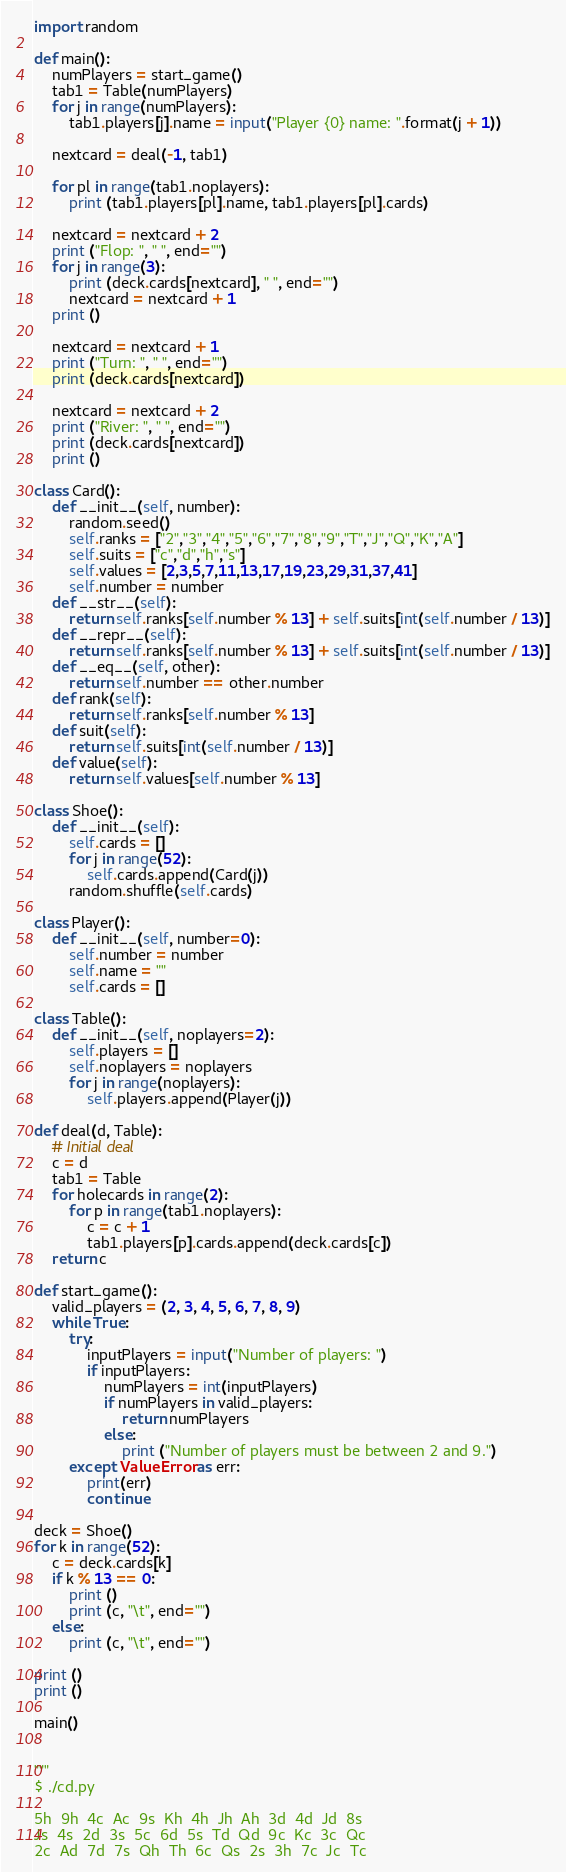<code> <loc_0><loc_0><loc_500><loc_500><_Python_>
import random

def main():
    numPlayers = start_game()
    tab1 = Table(numPlayers)
    for j in range(numPlayers):
        tab1.players[j].name = input("Player {0} name: ".format(j + 1))

    nextcard = deal(-1, tab1)

    for pl in range(tab1.noplayers):
        print (tab1.players[pl].name, tab1.players[pl].cards)

    nextcard = nextcard + 2
    print ("Flop: ", " ", end="")
    for j in range(3):
        print (deck.cards[nextcard], " ", end="")
        nextcard = nextcard + 1
    print ()

    nextcard = nextcard + 1
    print ("Turn: ", " ", end="")
    print (deck.cards[nextcard])

    nextcard = nextcard + 2
    print ("River: ", " ", end="")
    print (deck.cards[nextcard])
    print ()

class Card():
    def __init__(self, number):
        random.seed()
        self.ranks = ["2","3","4","5","6","7","8","9","T","J","Q","K","A"]
        self.suits = ["c","d","h","s"]
        self.values = [2,3,5,7,11,13,17,19,23,29,31,37,41]
        self.number = number
    def __str__(self):
        return self.ranks[self.number % 13] + self.suits[int(self.number / 13)]
    def __repr__(self):
        return self.ranks[self.number % 13] + self.suits[int(self.number / 13)]
    def __eq__(self, other):
        return self.number == other.number
    def rank(self):
        return self.ranks[self.number % 13]
    def suit(self):
        return self.suits[int(self.number / 13)]
    def value(self):
        return self.values[self.number % 13]

class Shoe():
    def __init__(self):
        self.cards = []
        for j in range(52):
            self.cards.append(Card(j))
        random.shuffle(self.cards)

class Player():
    def __init__(self, number=0):
        self.number = number
        self.name = ""
        self.cards = []

class Table():
    def __init__(self, noplayers=2):
        self.players = []
        self.noplayers = noplayers
        for j in range(noplayers):
            self.players.append(Player(j))

def deal(d, Table):
    # Initial deal
    c = d
    tab1 = Table
    for holecards in range(2):
        for p in range(tab1.noplayers):
            c = c + 1
            tab1.players[p].cards.append(deck.cards[c])
    return c

def start_game():
    valid_players = (2, 3, 4, 5, 6, 7, 8, 9)
    while True:
        try:
            inputPlayers = input("Number of players: ")
            if inputPlayers:
                numPlayers = int(inputPlayers)
                if numPlayers in valid_players:
                    return numPlayers
                else:
                    print ("Number of players must be between 2 and 9.")
        except ValueError as err:
            print(err)
            continue

deck = Shoe()
for k in range(52):
    c = deck.cards[k]
    if k % 13 == 0:
        print ()
        print (c, "\t", end="")
    else:
        print (c, "\t", end="")

print ()
print ()

main()


"""
$ ./cd.py

5h 	9h 	4c 	Ac 	9s 	Kh 	4h 	Jh 	Ah 	3d 	4d 	Jd 	8s
Js 	4s 	2d 	3s 	5c 	6d 	5s 	Td 	Qd 	9c 	Kc 	3c 	Qc
2c 	Ad 	7d 	7s 	Qh 	Th 	6c 	Qs 	2s 	3h 	7c 	Jc 	Tc</code> 